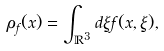Convert formula to latex. <formula><loc_0><loc_0><loc_500><loc_500>\rho _ { f } ( x ) = \int _ { \mathbb { R } ^ { 3 } } d \xi f ( x , \xi ) ,</formula> 